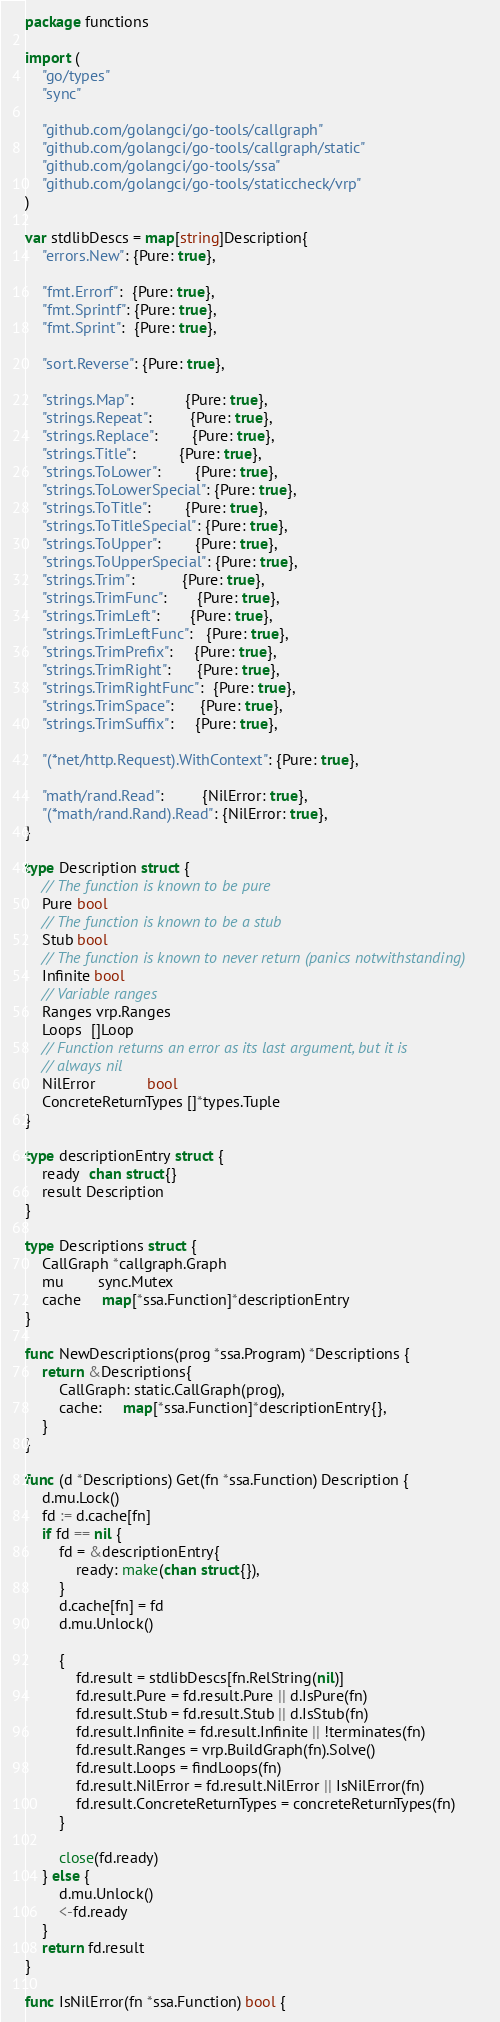Convert code to text. <code><loc_0><loc_0><loc_500><loc_500><_Go_>package functions

import (
	"go/types"
	"sync"

	"github.com/golangci/go-tools/callgraph"
	"github.com/golangci/go-tools/callgraph/static"
	"github.com/golangci/go-tools/ssa"
	"github.com/golangci/go-tools/staticcheck/vrp"
)

var stdlibDescs = map[string]Description{
	"errors.New": {Pure: true},

	"fmt.Errorf":  {Pure: true},
	"fmt.Sprintf": {Pure: true},
	"fmt.Sprint":  {Pure: true},

	"sort.Reverse": {Pure: true},

	"strings.Map":            {Pure: true},
	"strings.Repeat":         {Pure: true},
	"strings.Replace":        {Pure: true},
	"strings.Title":          {Pure: true},
	"strings.ToLower":        {Pure: true},
	"strings.ToLowerSpecial": {Pure: true},
	"strings.ToTitle":        {Pure: true},
	"strings.ToTitleSpecial": {Pure: true},
	"strings.ToUpper":        {Pure: true},
	"strings.ToUpperSpecial": {Pure: true},
	"strings.Trim":           {Pure: true},
	"strings.TrimFunc":       {Pure: true},
	"strings.TrimLeft":       {Pure: true},
	"strings.TrimLeftFunc":   {Pure: true},
	"strings.TrimPrefix":     {Pure: true},
	"strings.TrimRight":      {Pure: true},
	"strings.TrimRightFunc":  {Pure: true},
	"strings.TrimSpace":      {Pure: true},
	"strings.TrimSuffix":     {Pure: true},

	"(*net/http.Request).WithContext": {Pure: true},

	"math/rand.Read":         {NilError: true},
	"(*math/rand.Rand).Read": {NilError: true},
}

type Description struct {
	// The function is known to be pure
	Pure bool
	// The function is known to be a stub
	Stub bool
	// The function is known to never return (panics notwithstanding)
	Infinite bool
	// Variable ranges
	Ranges vrp.Ranges
	Loops  []Loop
	// Function returns an error as its last argument, but it is
	// always nil
	NilError            bool
	ConcreteReturnTypes []*types.Tuple
}

type descriptionEntry struct {
	ready  chan struct{}
	result Description
}

type Descriptions struct {
	CallGraph *callgraph.Graph
	mu        sync.Mutex
	cache     map[*ssa.Function]*descriptionEntry
}

func NewDescriptions(prog *ssa.Program) *Descriptions {
	return &Descriptions{
		CallGraph: static.CallGraph(prog),
		cache:     map[*ssa.Function]*descriptionEntry{},
	}
}

func (d *Descriptions) Get(fn *ssa.Function) Description {
	d.mu.Lock()
	fd := d.cache[fn]
	if fd == nil {
		fd = &descriptionEntry{
			ready: make(chan struct{}),
		}
		d.cache[fn] = fd
		d.mu.Unlock()

		{
			fd.result = stdlibDescs[fn.RelString(nil)]
			fd.result.Pure = fd.result.Pure || d.IsPure(fn)
			fd.result.Stub = fd.result.Stub || d.IsStub(fn)
			fd.result.Infinite = fd.result.Infinite || !terminates(fn)
			fd.result.Ranges = vrp.BuildGraph(fn).Solve()
			fd.result.Loops = findLoops(fn)
			fd.result.NilError = fd.result.NilError || IsNilError(fn)
			fd.result.ConcreteReturnTypes = concreteReturnTypes(fn)
		}

		close(fd.ready)
	} else {
		d.mu.Unlock()
		<-fd.ready
	}
	return fd.result
}

func IsNilError(fn *ssa.Function) bool {</code> 